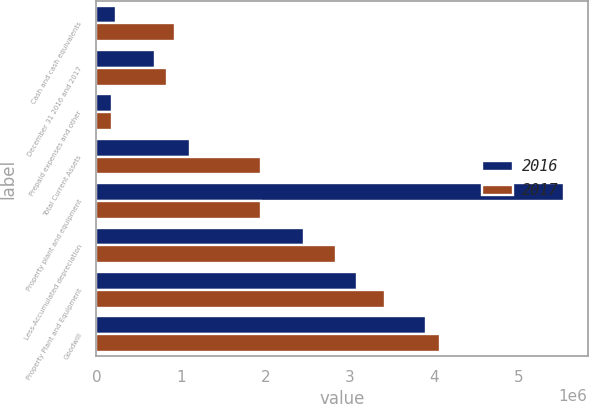Convert chart to OTSL. <chart><loc_0><loc_0><loc_500><loc_500><stacked_bar_chart><ecel><fcel>Cash and cash equivalents<fcel>December 31 2016 and 2017<fcel>Prepaid expenses and other<fcel>Total Current Assets<fcel>Property plant and equipment<fcel>Less-Accumulated depreciation<fcel>Property Plant and Equipment<fcel>Goodwill<nl><fcel>2016<fcel>236484<fcel>691249<fcel>184374<fcel>1.11211e+06<fcel>5.53578e+06<fcel>2.45246e+06<fcel>3.08333e+06<fcel>3.90502e+06<nl><fcel>2017<fcel>925699<fcel>835742<fcel>188874<fcel>1.95032e+06<fcel>1.95032e+06<fcel>2.83342e+06<fcel>3.41768e+06<fcel>4.07027e+06<nl></chart> 